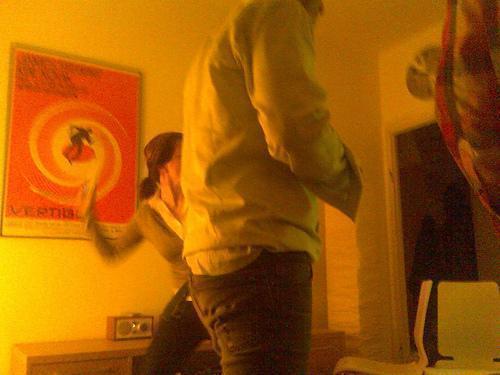What is the women about to do?
Choose the right answer from the provided options to respond to the question.
Options: Throw something, high five, play game, hit someone. Play game. 